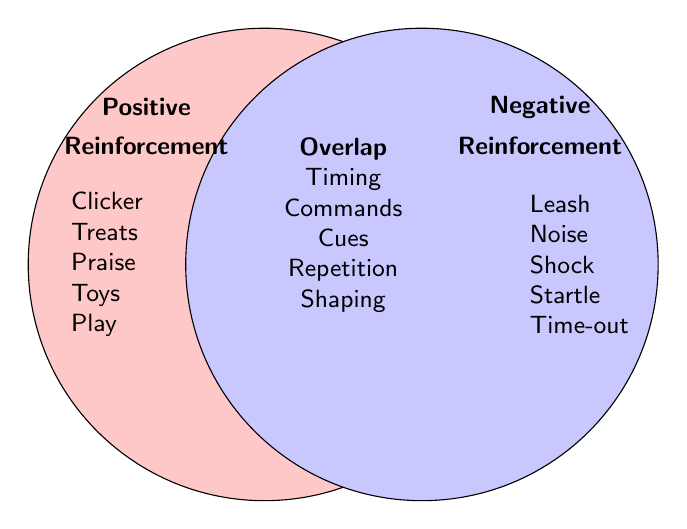What techniques fall under Positive Reinforcement? Positive reinforcement techniques are listed inside the left circle. These include Clicker training, Treat rewards, Praise and petting, Toy rewards, and Playtime.
Answer: Clicker training, Treat rewards, Praise and petting, Toy rewards, Playtime Which reinforcement techniques are specifically categorized as Negative Reinforcement? Negative reinforcement techniques are listed inside the right circle. These include Leash corrections, Noise aversion therapy, Shock collars, Startling sounds, and Time-outs.
Answer: Leash corrections, Noise aversion therapy, Shock collars, Startling sounds, Time-outs Name a technique that appears in both Positive and Negative Reinforcement categories. Techniques that appear in both categories are listed in the intersection area of the circles. This includes Consistent timing, Voice commands, Sound cues, Repetition, and Behavior shaping.
Answer: Consistent timing, Voice commands, Sound cues, Repetition, Behavior shaping Compare Positive Reinforcement to Negative Reinforcement by counting the number of unique techniques in each category. Which category has more techniques? Count the number of techniques listed uniquely in each circle. Positive Reinforcement has 5 techniques, and Negative Reinforcement also has 5 unique techniques.
Answer: Both have the same number What is the primary differentiator between Positive Reinforcement and Negative Reinforcement techniques for behavior shaping? Focus on the techniques listed in each category relating to 'Behavior shaping'. Only Positive Reinforcement uniquely mentions techniques like Clicker training, Treat rewards, etc., while other behavioral shaping is shared.
Answer: Unique techniques like Clicker training, Treat rewards Which category includes voice commands, and does any other technique overlap with it? Voice commands fall in the intersection area, indicating it overlaps by appearing in both categories.
Answer: Positive and Negative Reinforcement 